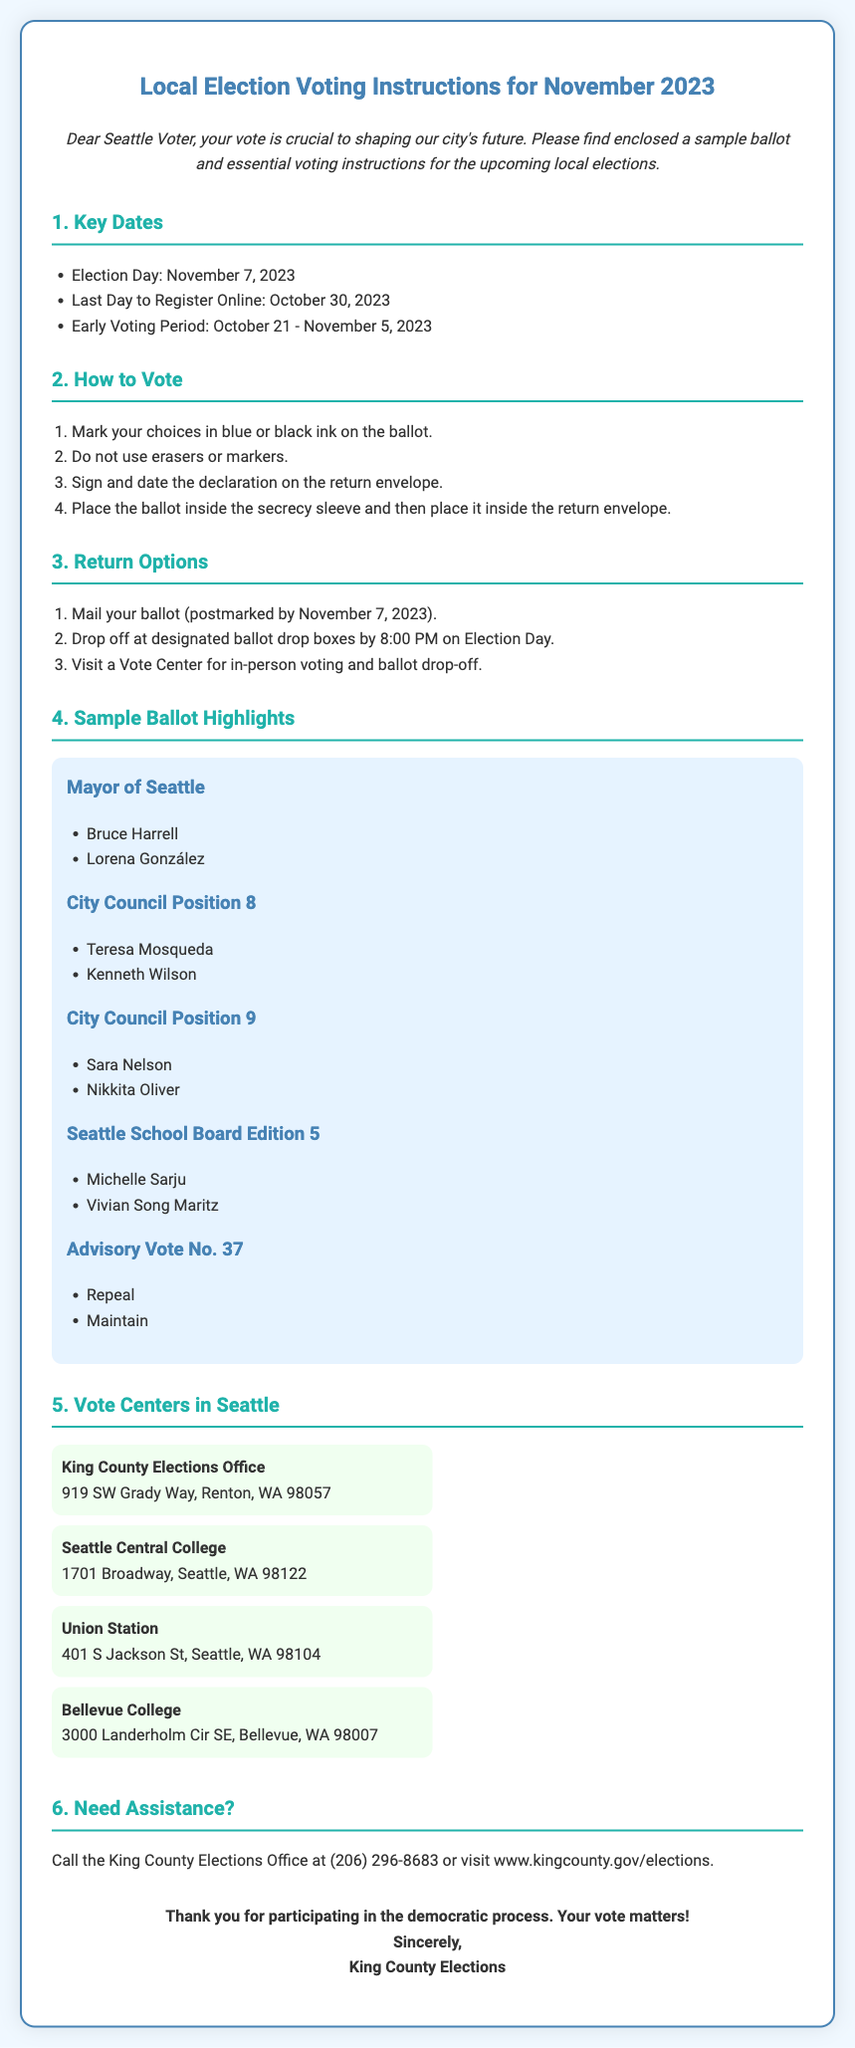what is Election Day? Election Day is explicitly mentioned in the document as November 7, 2023.
Answer: November 7, 2023 what is the last day to register online? The last day to register online is clearly stated as October 30, 2023.
Answer: October 30, 2023 who are the candidates for Mayor of Seattle? The document lists Bruce Harrell and Lorena González as the candidates for Mayor of Seattle.
Answer: Bruce Harrell, Lorena González how should you mark your choices on the ballot? The instructions specify that choices should be marked in blue or black ink on the ballot.
Answer: blue or black ink what time must ballots be dropped off on Election Day? The document indicates that ballots must be dropped off by 8:00 PM on Election Day.
Answer: 8:00 PM where is the King County Elections Office located? The document includes the address of the King County Elections Office as 919 SW Grady Way, Renton, WA 98057.
Answer: 919 SW Grady Way, Renton, WA 98057 what is the early voting period? The early voting period is stated as October 21 - November 5, 2023.
Answer: October 21 - November 5, 2023 how can voters get assistance? The document advises voters to call the King County Elections Office or visit their website for assistance.
Answer: Call (206) 296-8683 what is a requirement for signing the return envelope? The instructions specify that voters must sign and date the declaration on the return envelope.
Answer: Sign and date the declaration 